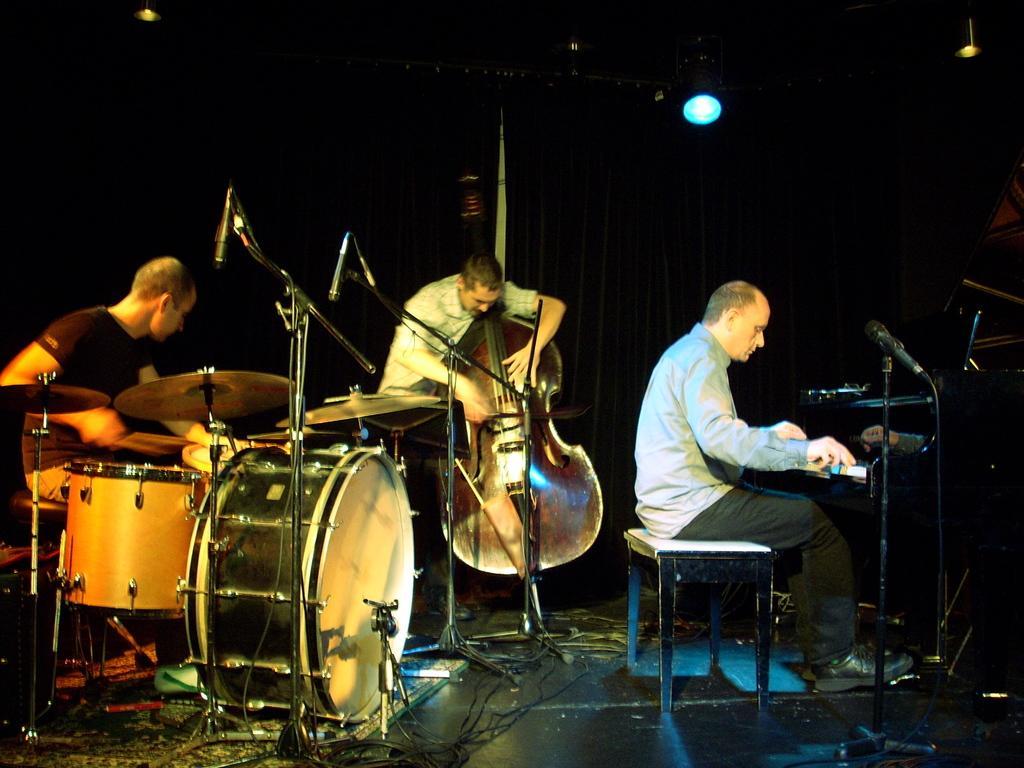Can you describe this image briefly? There is a group of people. They are playing a musical instruments. 